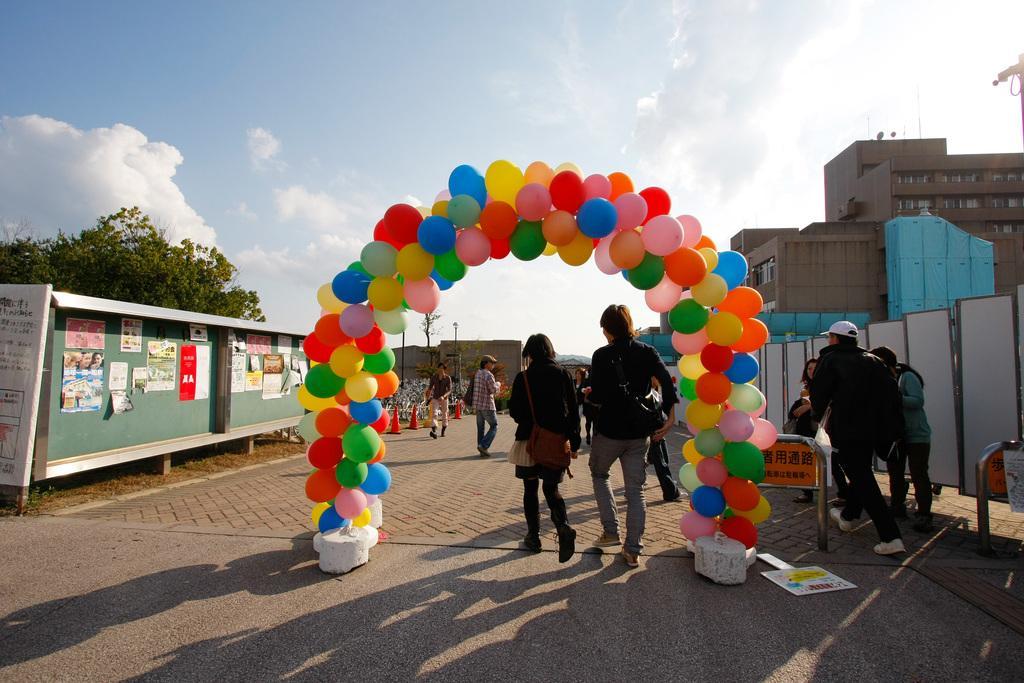How would you summarize this image in a sentence or two? In this image we can see people, road, traffic cones, poles, trees, boards, banner, posters, shed, balloon arch, and buildings. In the background there is sky with clouds. 